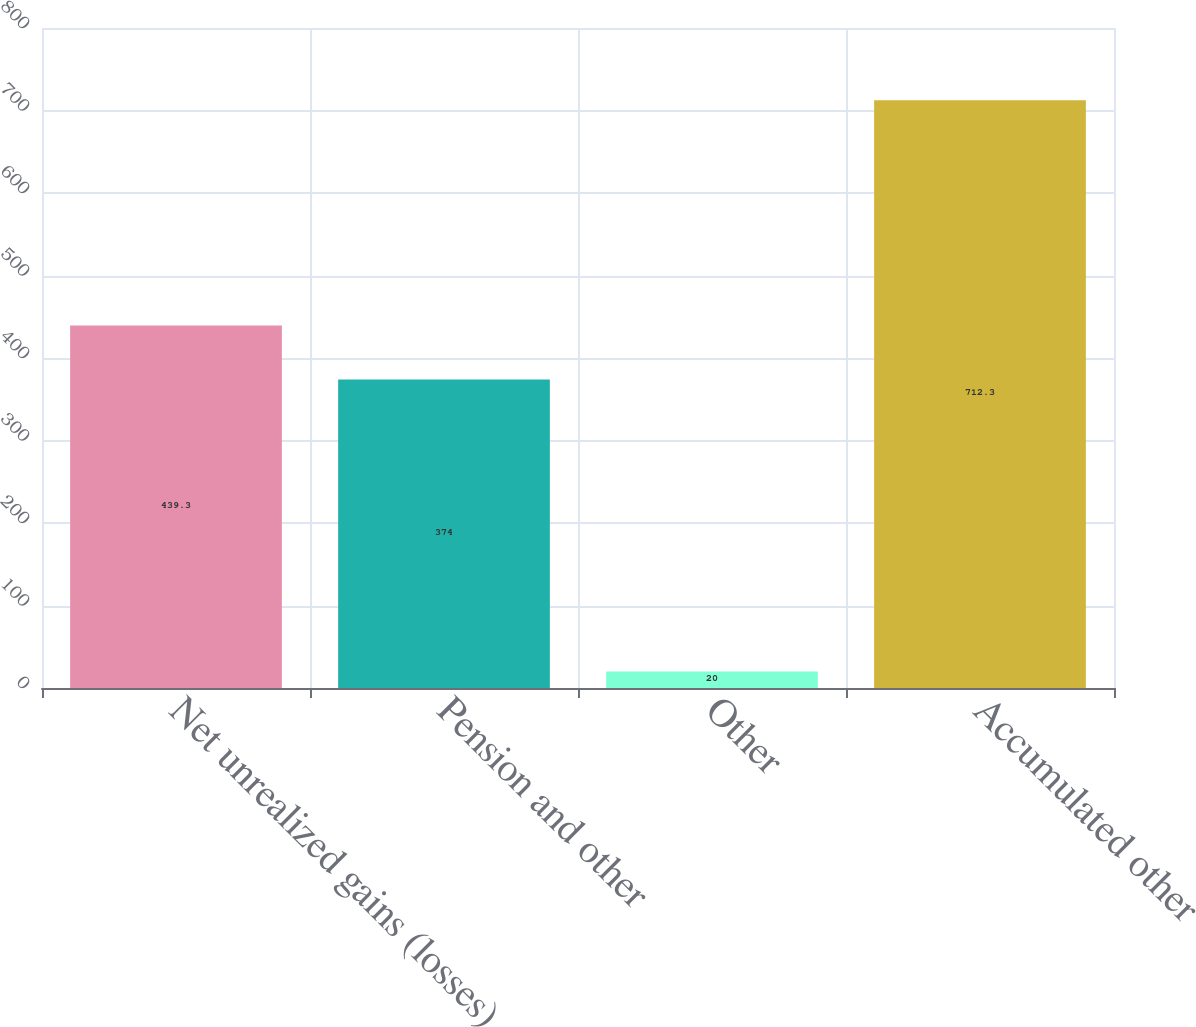Convert chart. <chart><loc_0><loc_0><loc_500><loc_500><bar_chart><fcel>Net unrealized gains (losses)<fcel>Pension and other<fcel>Other<fcel>Accumulated other<nl><fcel>439.3<fcel>374<fcel>20<fcel>712.3<nl></chart> 